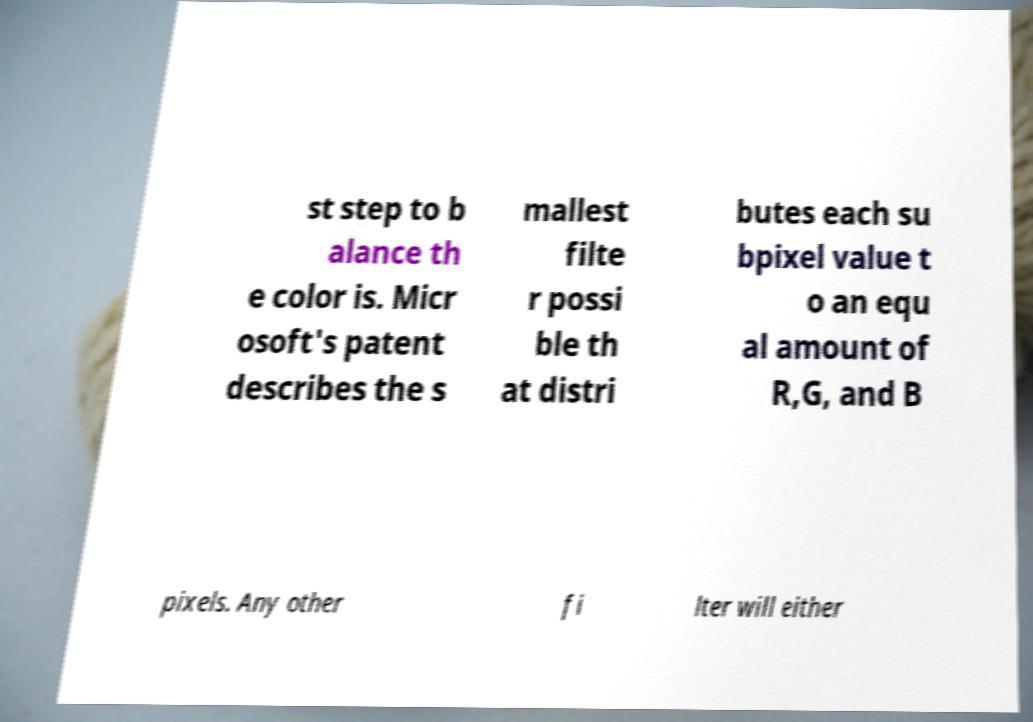I need the written content from this picture converted into text. Can you do that? st step to b alance th e color is. Micr osoft's patent describes the s mallest filte r possi ble th at distri butes each su bpixel value t o an equ al amount of R,G, and B pixels. Any other fi lter will either 